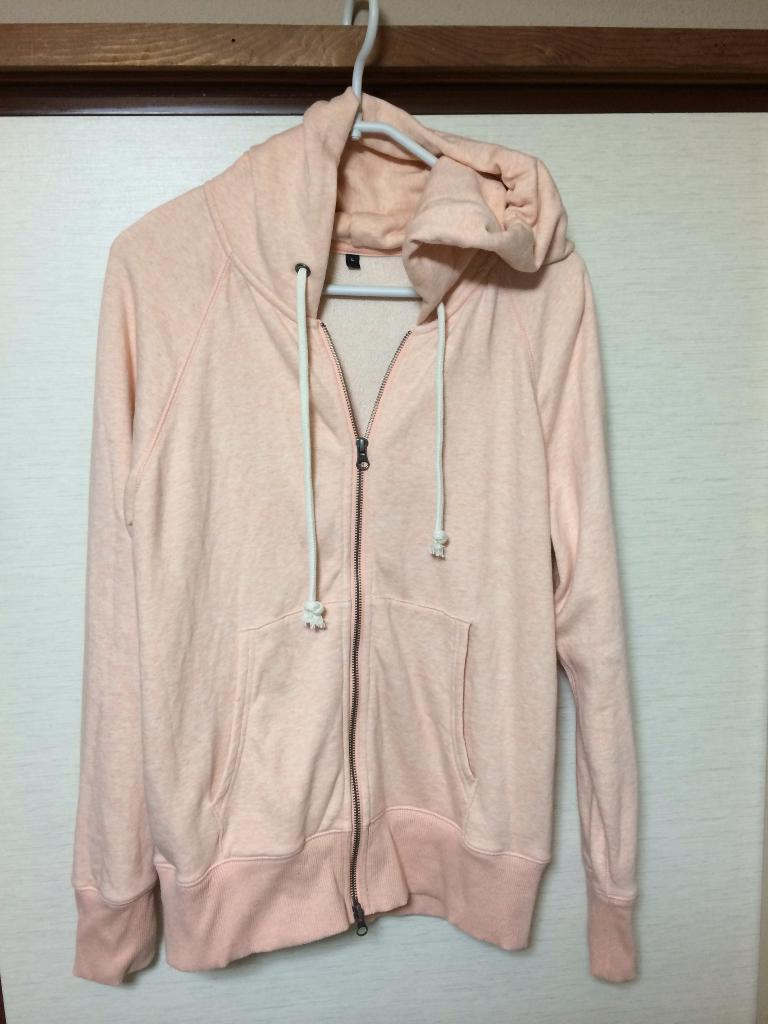What type of clothing item is in the image? There is a sweater in the image. How is the sweater positioned in the image? The sweater is hanging on a hanger. What color is the background of the image? The background of the image is white. What material can be seen in the image besides the sweater? There is a wooden sheet in the image. Where is the river located in the image? There is no river present in the image. What type of tent can be seen in the image? There is no tent present in the image. 